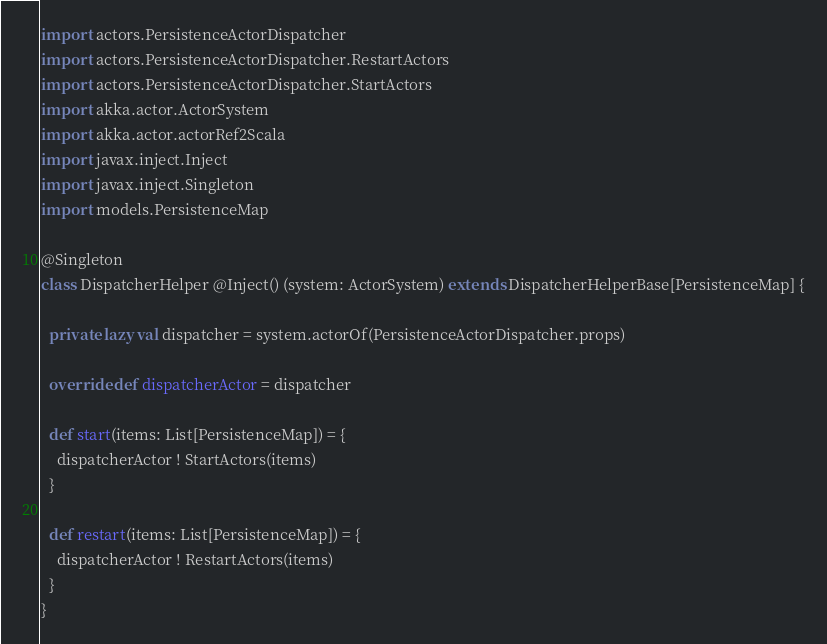<code> <loc_0><loc_0><loc_500><loc_500><_Scala_>
import actors.PersistenceActorDispatcher
import actors.PersistenceActorDispatcher.RestartActors
import actors.PersistenceActorDispatcher.StartActors
import akka.actor.ActorSystem
import akka.actor.actorRef2Scala
import javax.inject.Inject
import javax.inject.Singleton
import models.PersistenceMap

@Singleton
class DispatcherHelper @Inject() (system: ActorSystem) extends DispatcherHelperBase[PersistenceMap] {
  
  private lazy val dispatcher = system.actorOf(PersistenceActorDispatcher.props)
  
  override def dispatcherActor = dispatcher
  
  def start(items: List[PersistenceMap]) = {
    dispatcherActor ! StartActors(items)
  }
  
  def restart(items: List[PersistenceMap]) = {
    dispatcherActor ! RestartActors(items)
  }
}

</code> 